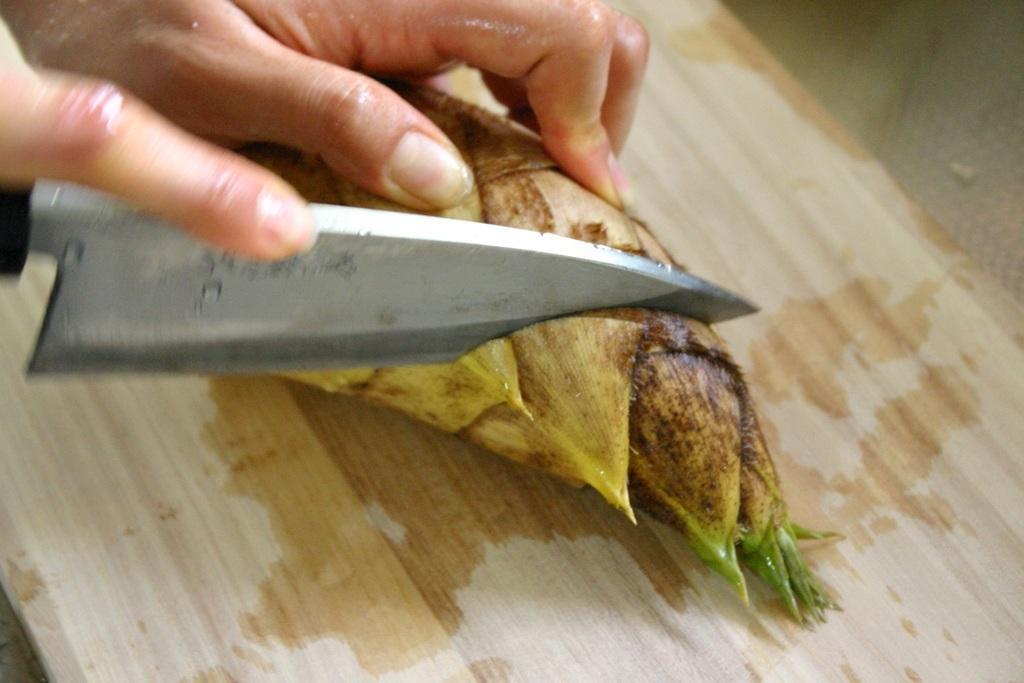Could you give a brief overview of what you see in this image? In this image we can see a person´s hand cutting a vegetable with a knife on the chopping board. 